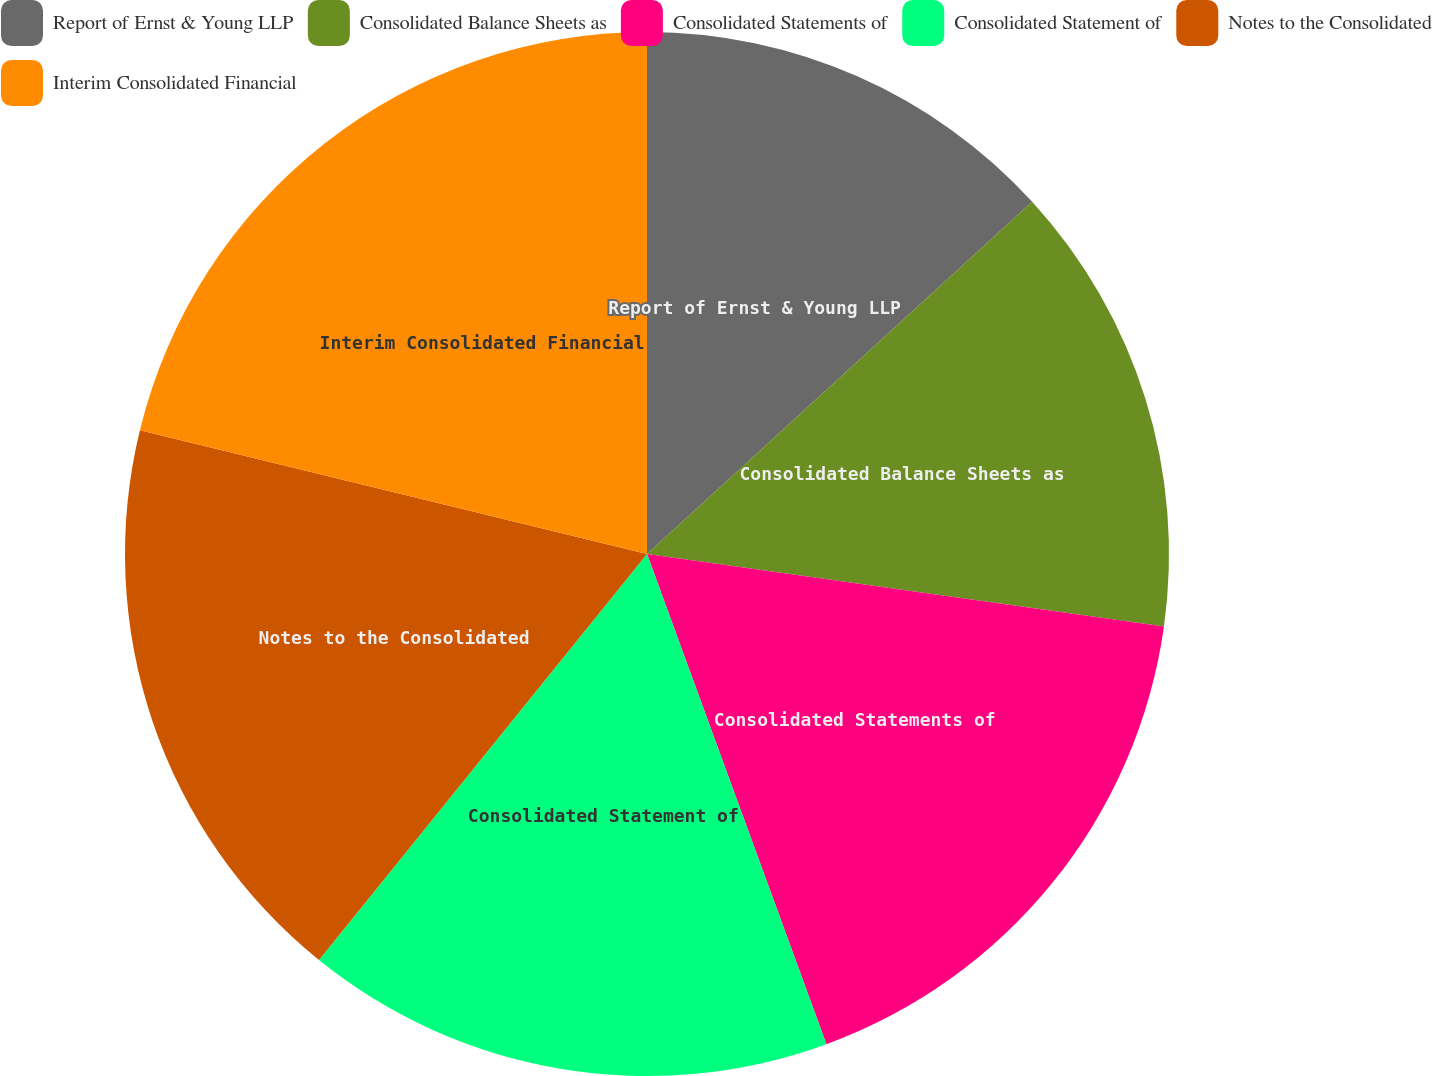Convert chart to OTSL. <chart><loc_0><loc_0><loc_500><loc_500><pie_chart><fcel>Report of Ernst & Young LLP<fcel>Consolidated Balance Sheets as<fcel>Consolidated Statements of<fcel>Consolidated Statement of<fcel>Notes to the Consolidated<fcel>Interim Consolidated Financial<nl><fcel>13.21%<fcel>14.01%<fcel>17.2%<fcel>16.4%<fcel>18.0%<fcel>21.19%<nl></chart> 